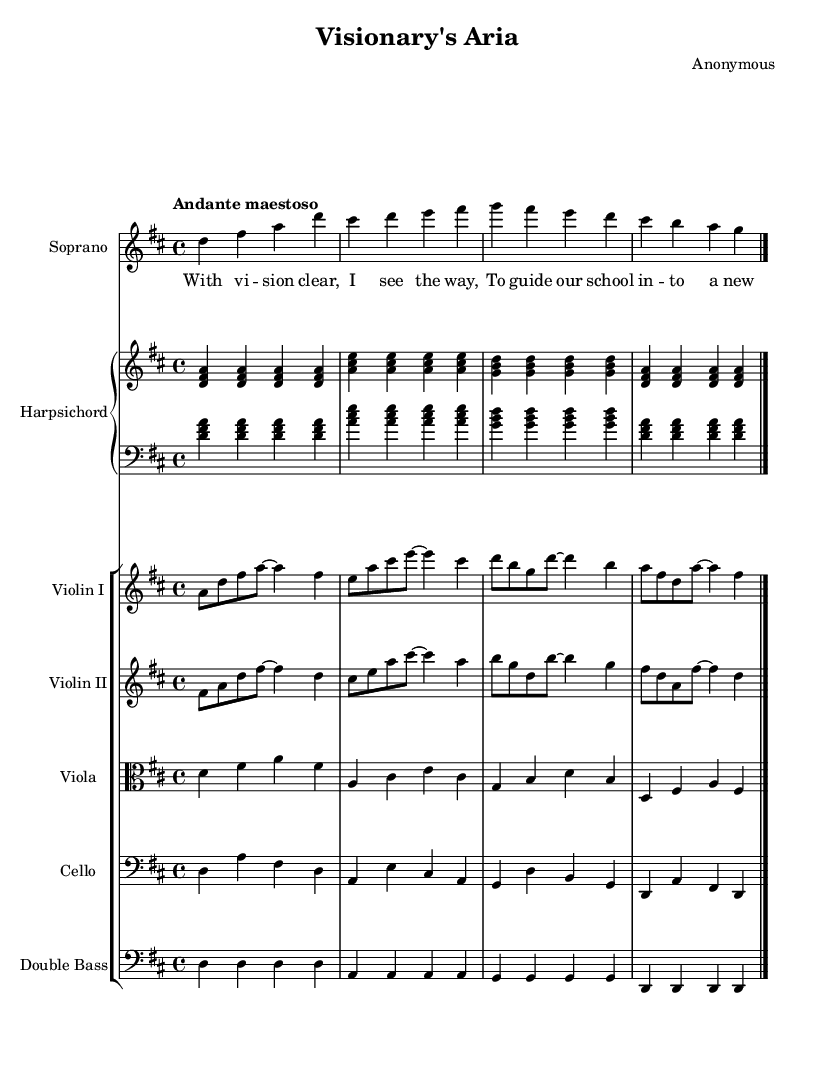What is the key signature of this music? The key signature is indicated at the beginning of the score. In this case, there are two sharps, which correspond to the key of D major.
Answer: D major What is the time signature of this music? The time signature is displayed at the beginning of the piece, showing the number of beats in each measure. Here, it is 4/4, indicating four beats per measure.
Answer: 4/4 What is the tempo marking of this piece? The tempo marking is found above the musical staff, indicating the speed at which the piece should be performed. "Andante maestoso" suggests a moderate pace with a majestic feeling.
Answer: Andante maestoso Which instrument plays the main melody? The main melody is often carried by the soprano voice, as indicated by the score section for the soprano. This voice has the most prominent part in this excerpt.
Answer: Soprano How many measures are in the soprano part? The soprano part can be counted by examining the musical notation. In this excerpt, there are four measures before the final barline.
Answer: Four measures What is the function of the harpsichord in this piece? The harpsichord provides harmonic support and texture. By looking at the score, we see it plays chords and bass lines throughout the piece, interacting with the other instruments and the soprano vocal line.
Answer: Harmonic support What does the term "aria" signify in this opera? An aria is a solo vocal piece typically showcasing the singer's voice and emotion, often reflecting a character's thoughts or feelings in the context of the opera. In this case, it emphasizes the visionary leader's perspective.
Answer: Solo vocal piece 